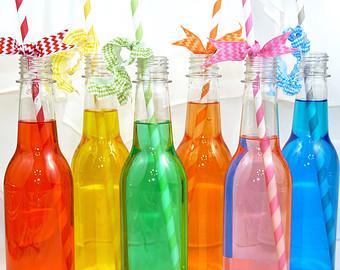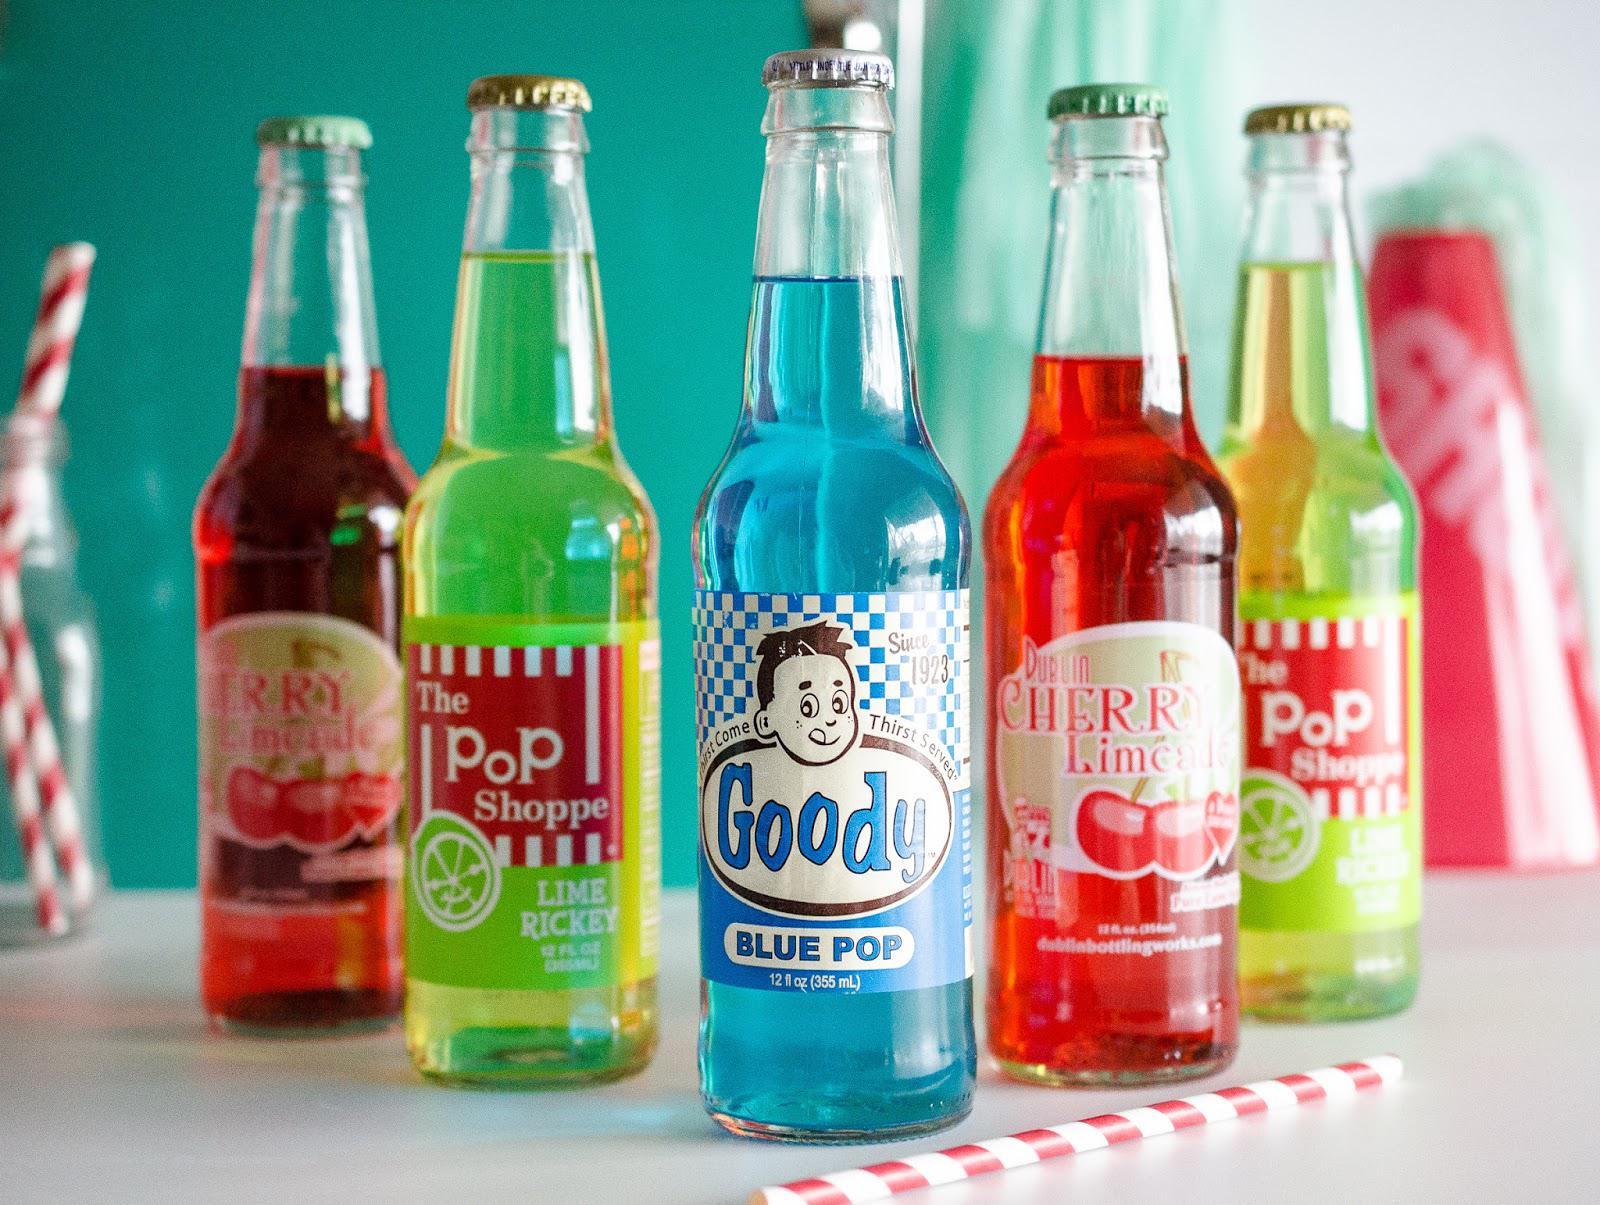The first image is the image on the left, the second image is the image on the right. For the images shown, is this caption "The right image shows one bottle leaning on an upright bottle, in front of a row of similar bottles shown in different colors." true? Answer yes or no. No. The first image is the image on the left, the second image is the image on the right. Examine the images to the left and right. Is the description "One of the bottles is tilted and being propped up by another bottle." accurate? Answer yes or no. No. 